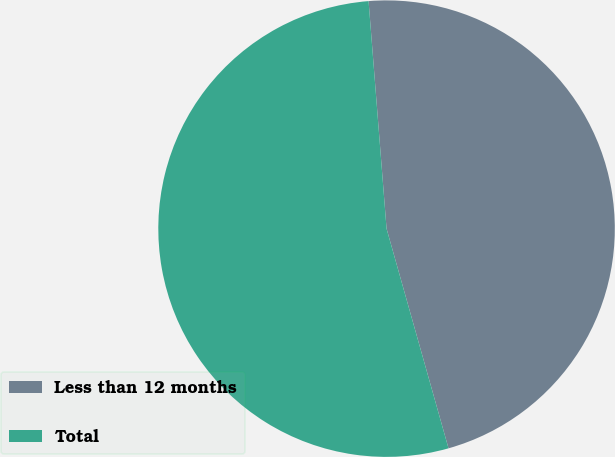Convert chart to OTSL. <chart><loc_0><loc_0><loc_500><loc_500><pie_chart><fcel>Less than 12 months<fcel>Total<nl><fcel>46.88%<fcel>53.12%<nl></chart> 